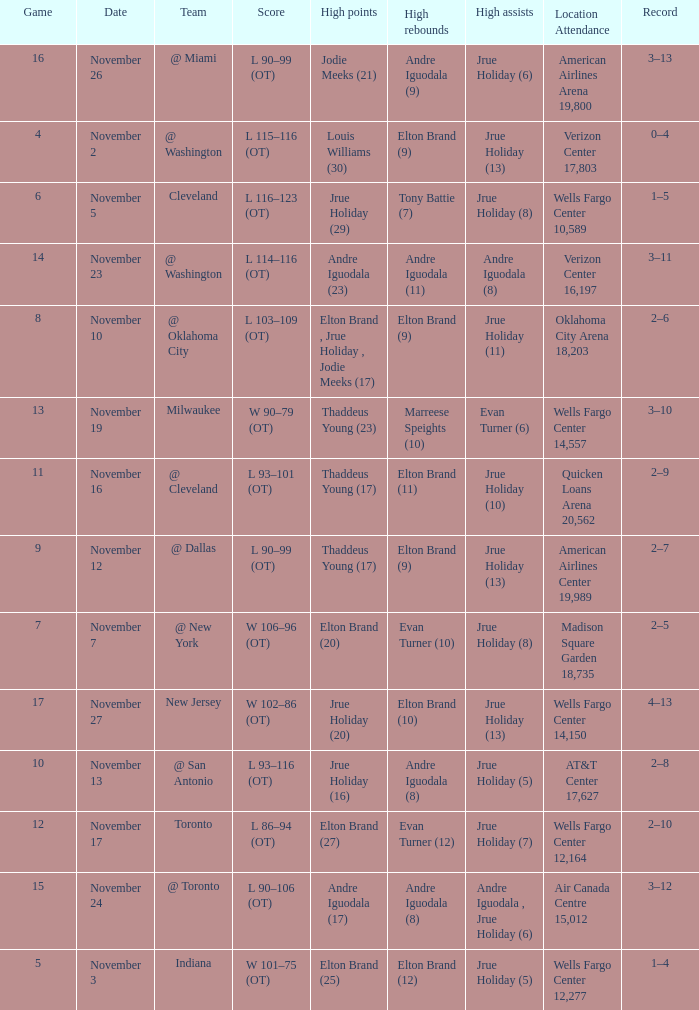Could you parse the entire table as a dict? {'header': ['Game', 'Date', 'Team', 'Score', 'High points', 'High rebounds', 'High assists', 'Location Attendance', 'Record'], 'rows': [['16', 'November 26', '@ Miami', 'L 90–99 (OT)', 'Jodie Meeks (21)', 'Andre Iguodala (9)', 'Jrue Holiday (6)', 'American Airlines Arena 19,800', '3–13'], ['4', 'November 2', '@ Washington', 'L 115–116 (OT)', 'Louis Williams (30)', 'Elton Brand (9)', 'Jrue Holiday (13)', 'Verizon Center 17,803', '0–4'], ['6', 'November 5', 'Cleveland', 'L 116–123 (OT)', 'Jrue Holiday (29)', 'Tony Battie (7)', 'Jrue Holiday (8)', 'Wells Fargo Center 10,589', '1–5'], ['14', 'November 23', '@ Washington', 'L 114–116 (OT)', 'Andre Iguodala (23)', 'Andre Iguodala (11)', 'Andre Iguodala (8)', 'Verizon Center 16,197', '3–11'], ['8', 'November 10', '@ Oklahoma City', 'L 103–109 (OT)', 'Elton Brand , Jrue Holiday , Jodie Meeks (17)', 'Elton Brand (9)', 'Jrue Holiday (11)', 'Oklahoma City Arena 18,203', '2–6'], ['13', 'November 19', 'Milwaukee', 'W 90–79 (OT)', 'Thaddeus Young (23)', 'Marreese Speights (10)', 'Evan Turner (6)', 'Wells Fargo Center 14,557', '3–10'], ['11', 'November 16', '@ Cleveland', 'L 93–101 (OT)', 'Thaddeus Young (17)', 'Elton Brand (11)', 'Jrue Holiday (10)', 'Quicken Loans Arena 20,562', '2–9'], ['9', 'November 12', '@ Dallas', 'L 90–99 (OT)', 'Thaddeus Young (17)', 'Elton Brand (9)', 'Jrue Holiday (13)', 'American Airlines Center 19,989', '2–7'], ['7', 'November 7', '@ New York', 'W 106–96 (OT)', 'Elton Brand (20)', 'Evan Turner (10)', 'Jrue Holiday (8)', 'Madison Square Garden 18,735', '2–5'], ['17', 'November 27', 'New Jersey', 'W 102–86 (OT)', 'Jrue Holiday (20)', 'Elton Brand (10)', 'Jrue Holiday (13)', 'Wells Fargo Center 14,150', '4–13'], ['10', 'November 13', '@ San Antonio', 'L 93–116 (OT)', 'Jrue Holiday (16)', 'Andre Iguodala (8)', 'Jrue Holiday (5)', 'AT&T Center 17,627', '2–8'], ['12', 'November 17', 'Toronto', 'L 86–94 (OT)', 'Elton Brand (27)', 'Evan Turner (12)', 'Jrue Holiday (7)', 'Wells Fargo Center 12,164', '2–10'], ['15', 'November 24', '@ Toronto', 'L 90–106 (OT)', 'Andre Iguodala (17)', 'Andre Iguodala (8)', 'Andre Iguodala , Jrue Holiday (6)', 'Air Canada Centre 15,012', '3–12'], ['5', 'November 3', 'Indiana', 'W 101–75 (OT)', 'Elton Brand (25)', 'Elton Brand (12)', 'Jrue Holiday (5)', 'Wells Fargo Center 12,277', '1–4']]} How many games are shown for the game where andre iguodala (9) had the high rebounds? 1.0. 